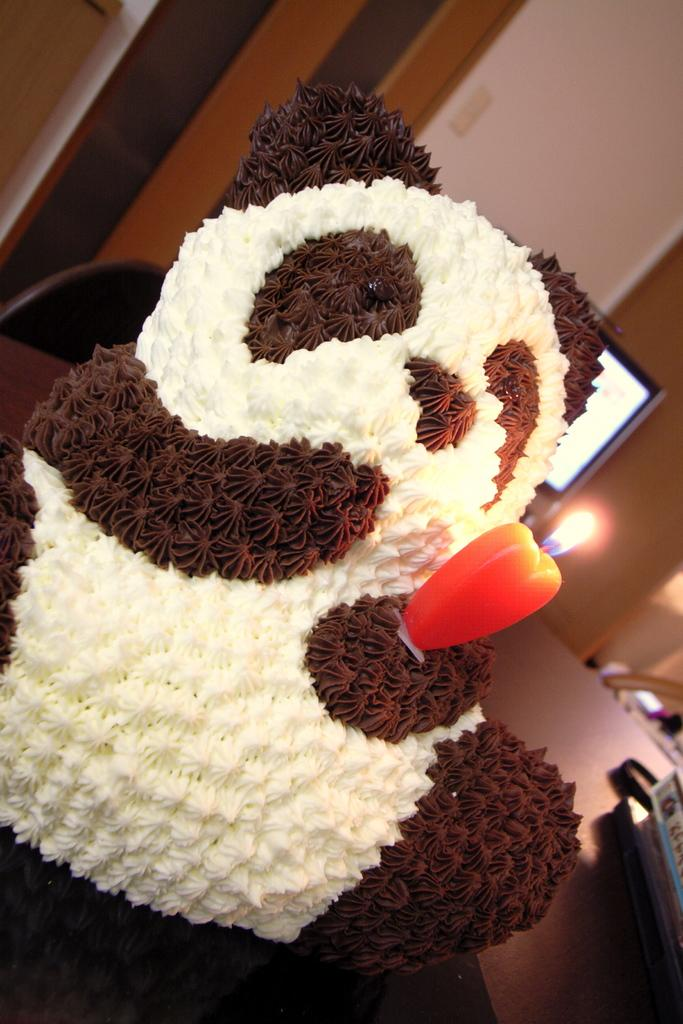What is the doll holding in the image? The doll is holding a candle in the image. What can be seen on the table in the image? There are objects on the table in the image. What piece of furniture is visible in the image? There is a chair in the image. What is visible in the background of the image? There is a television and a wall in the background of the image. How many pigs are sitting on the chair in the image? There are no pigs present in the image; the chair is empty. 